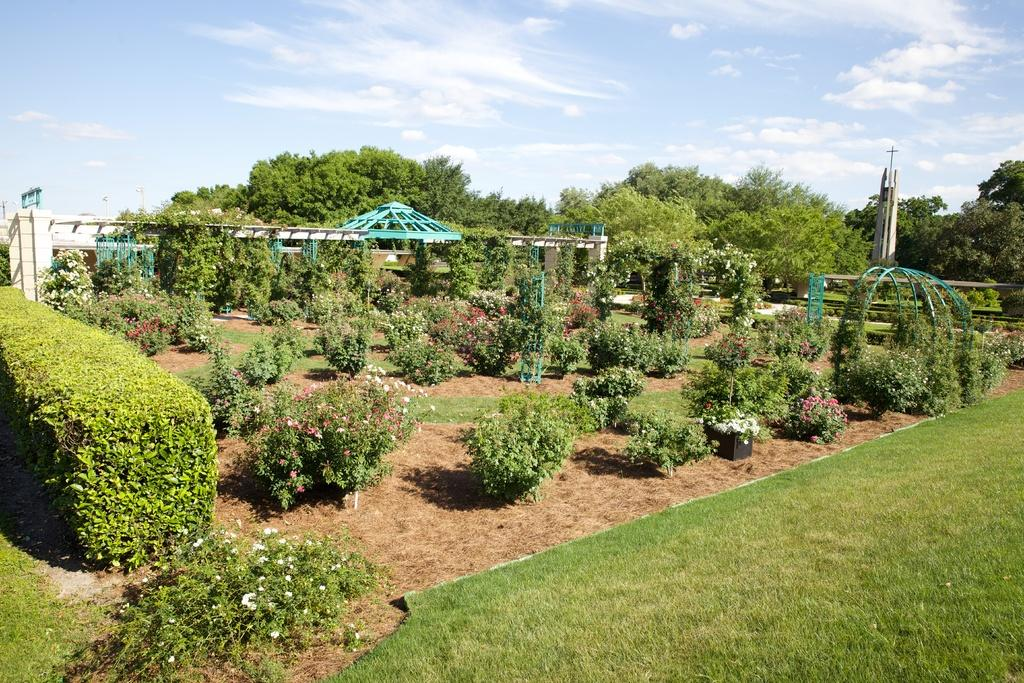What type of vegetation can be seen in the image? There is grass and plants in the image. What feature of the plants can be observed? The plants have flowers. What architectural elements are present in the image? There are pillars and a tower in the image. What other objects can be seen in the image? There are rods in the image. What is visible in the background of the image? There are trees and the sky in the background of the image. What can be seen in the sky? There are clouds in the sky. What type of liquid can be seen flowing through the patch in the image? There is no liquid or patch present in the image. 